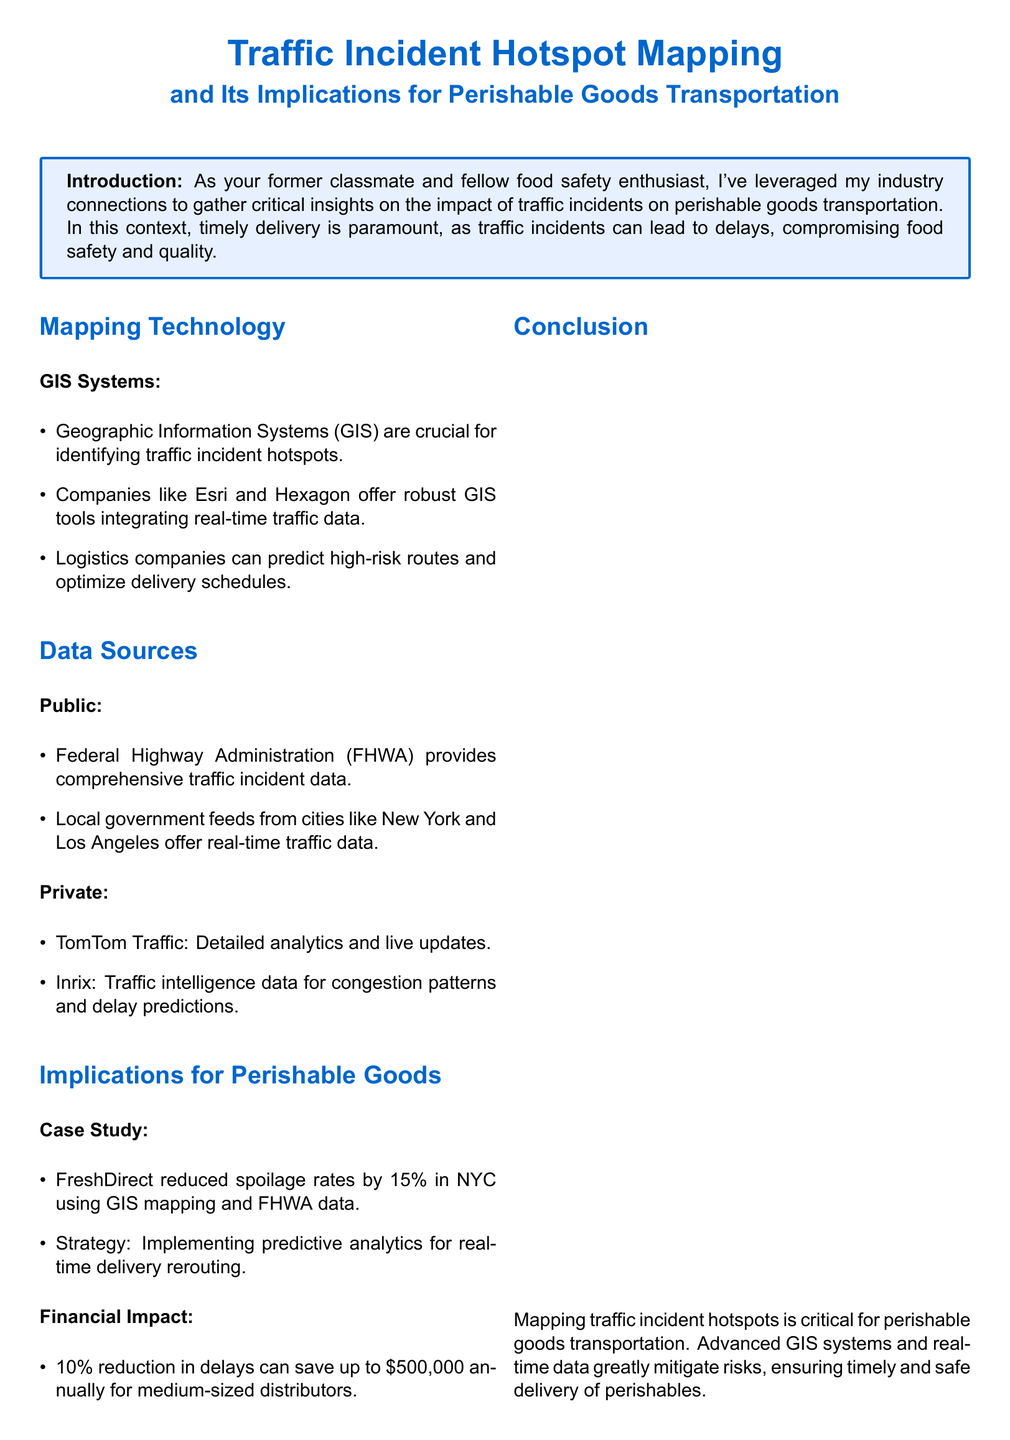What is the purpose of GIS systems in this report? GIS systems are crucial for identifying traffic incident hotspots.
Answer: Identifying traffic incident hotspots Which company reduced spoilage rates by 15% using GIS mapping? FreshDirect implemented GIS mapping and FHWA data for reducing spoilage rates in NYC.
Answer: FreshDirect What percentage reduction in delays can save medium-sized distributors up to $500,000 annually? A 10% reduction in delays can save medium-sized distributors significant amounts annually.
Answer: 10% Which two companies provide real-time traffic data mentioned in the report? TomTom Traffic and Inrix are cited for providing traffic intelligence and analytics.
Answer: TomTom Traffic and Inrix What type of data does the Federal Highway Administration provide? The FHWA provides comprehensive traffic incident data.
Answer: Comprehensive traffic incident data What is the financial implication of a 10% reduction in delivery delays? A 10% reduction in delays leads to potential savings of $500,000 for distributors.
Answer: $500,000 What strategy did FreshDirect implement to reduce spoilage? The strategy involved implementing predictive analytics for real-time delivery rerouting.
Answer: Predictive analytics for real-time delivery rerouting What is the main focus of the conclusion in this report? The conclusion emphasizes the critical role of mapping traffic incident hotspots for perishable goods transportation.
Answer: Mapping traffic incident hotspots What does the call to action emphasize? The call to action emphasizes collaboration on enhancing food safety measures.
Answer: Collaboration on enhancing food safety measures 